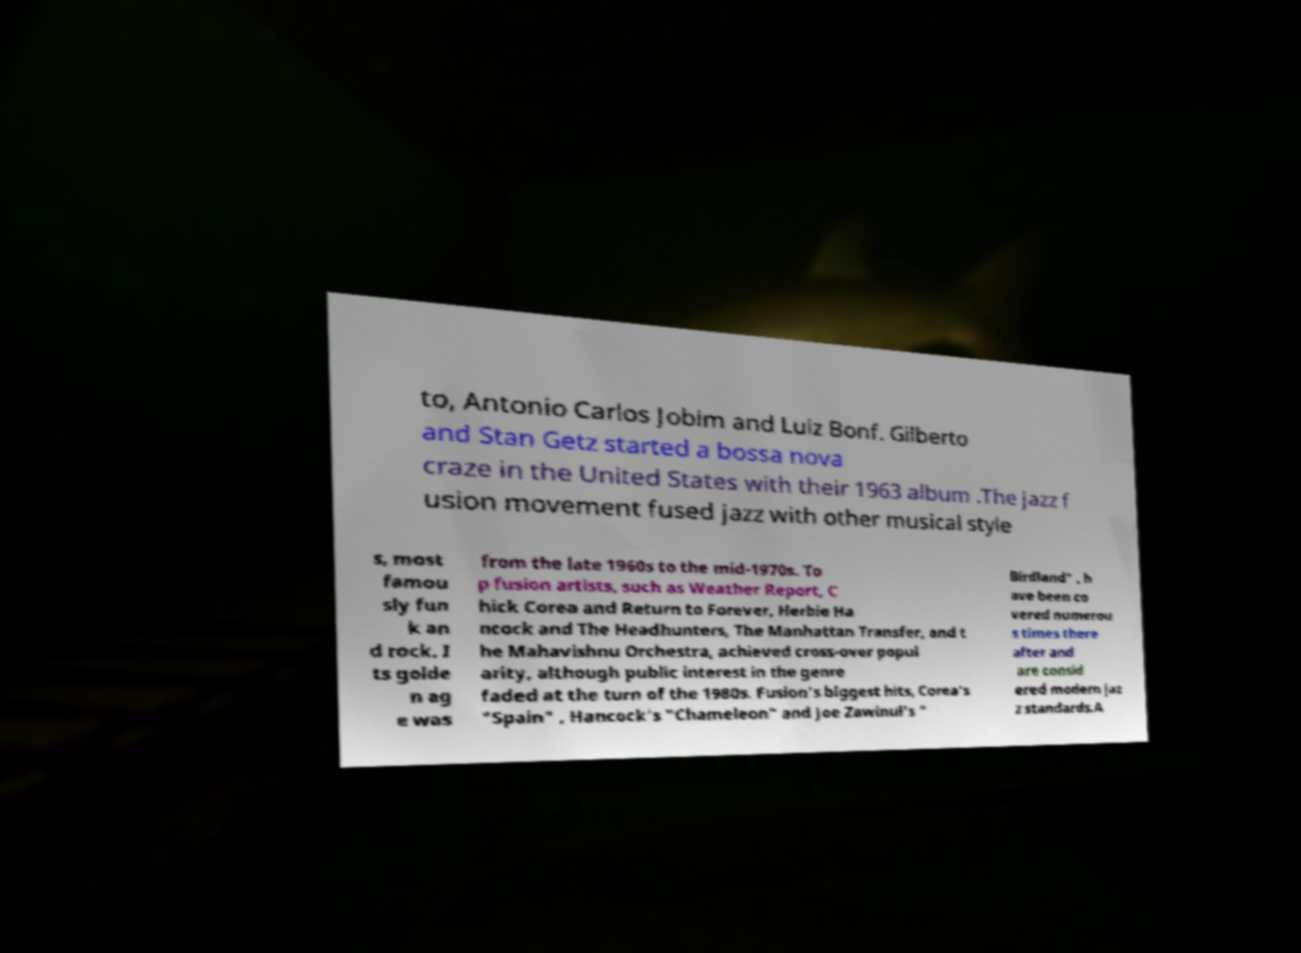What messages or text are displayed in this image? I need them in a readable, typed format. to, Antonio Carlos Jobim and Luiz Bonf. Gilberto and Stan Getz started a bossa nova craze in the United States with their 1963 album .The jazz f usion movement fused jazz with other musical style s, most famou sly fun k an d rock. I ts golde n ag e was from the late 1960s to the mid-1970s. To p fusion artists, such as Weather Report, C hick Corea and Return to Forever, Herbie Ha ncock and The Headhunters, The Manhattan Transfer, and t he Mahavishnu Orchestra, achieved cross-over popul arity, although public interest in the genre faded at the turn of the 1980s. Fusion's biggest hits, Corea's "Spain" , Hancock's "Chameleon" and Joe Zawinul's " Birdland" , h ave been co vered numerou s times there after and are consid ered modern jaz z standards.A 